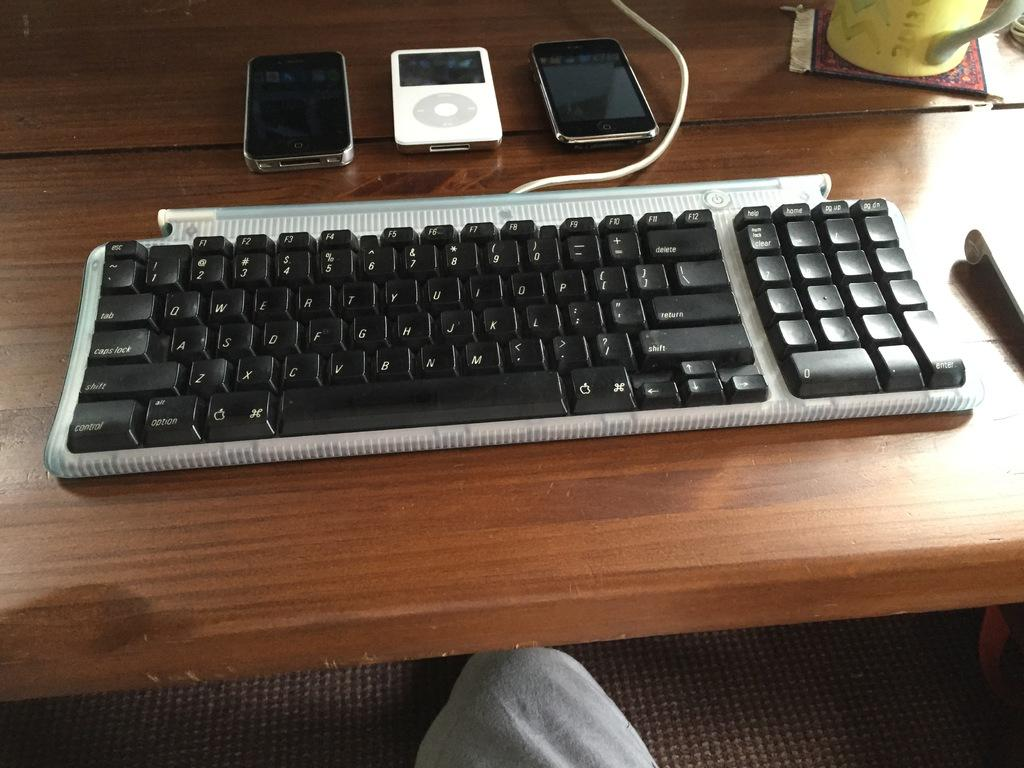What electronic device is visible in the image? There is a keyboard in the image. What other electronic device can be seen in the image? There is a mobile and an iPod in the image. Where are these devices located? All these objects are on a table. What type of picture is hanging on the wall behind the table? There is no mention of a picture or a wall in the provided facts, so we cannot determine if there is a picture hanging on the wall. 